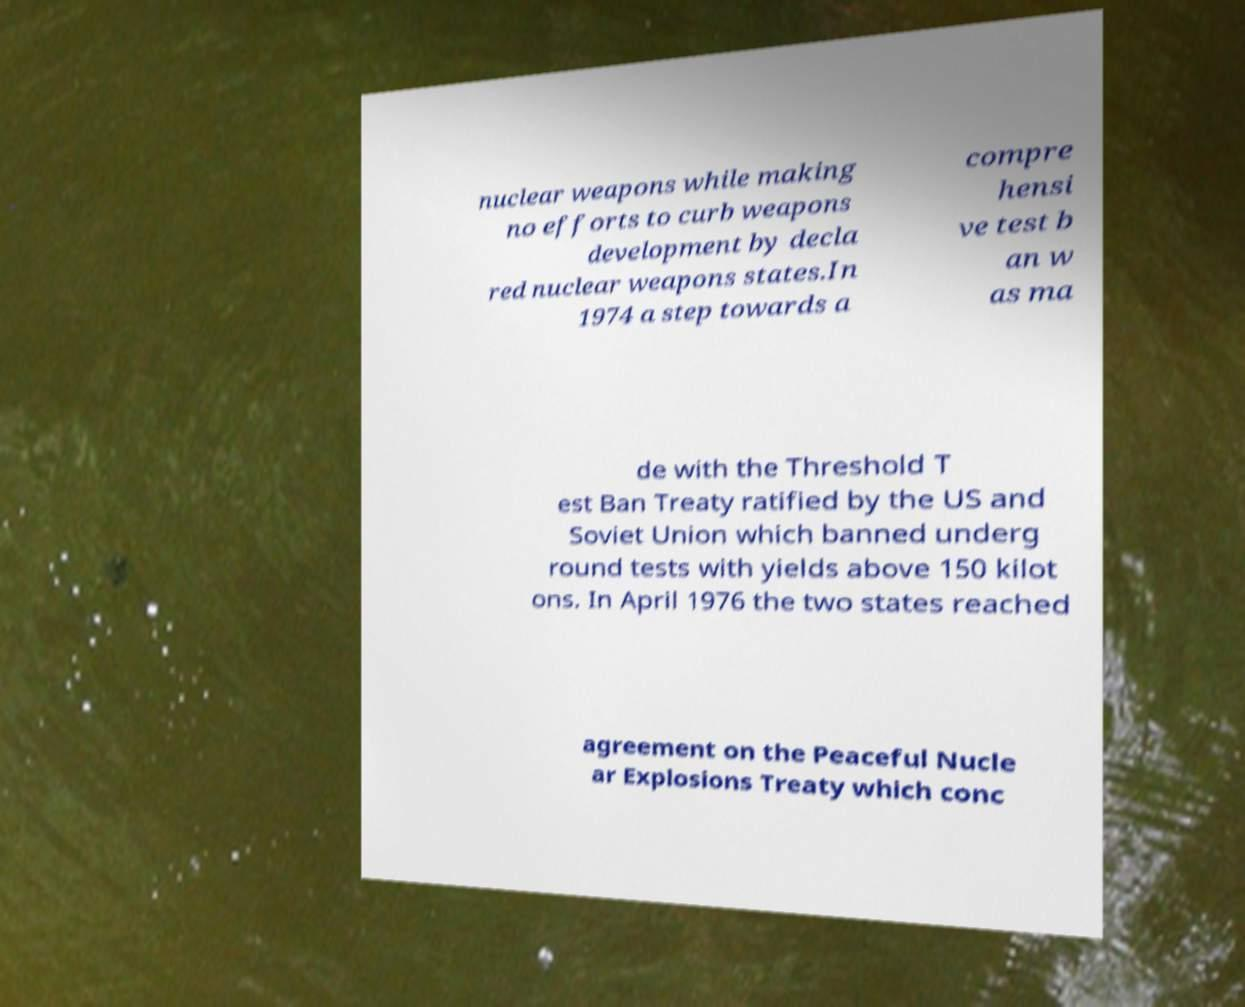Please identify and transcribe the text found in this image. nuclear weapons while making no efforts to curb weapons development by decla red nuclear weapons states.In 1974 a step towards a compre hensi ve test b an w as ma de with the Threshold T est Ban Treaty ratified by the US and Soviet Union which banned underg round tests with yields above 150 kilot ons. In April 1976 the two states reached agreement on the Peaceful Nucle ar Explosions Treaty which conc 